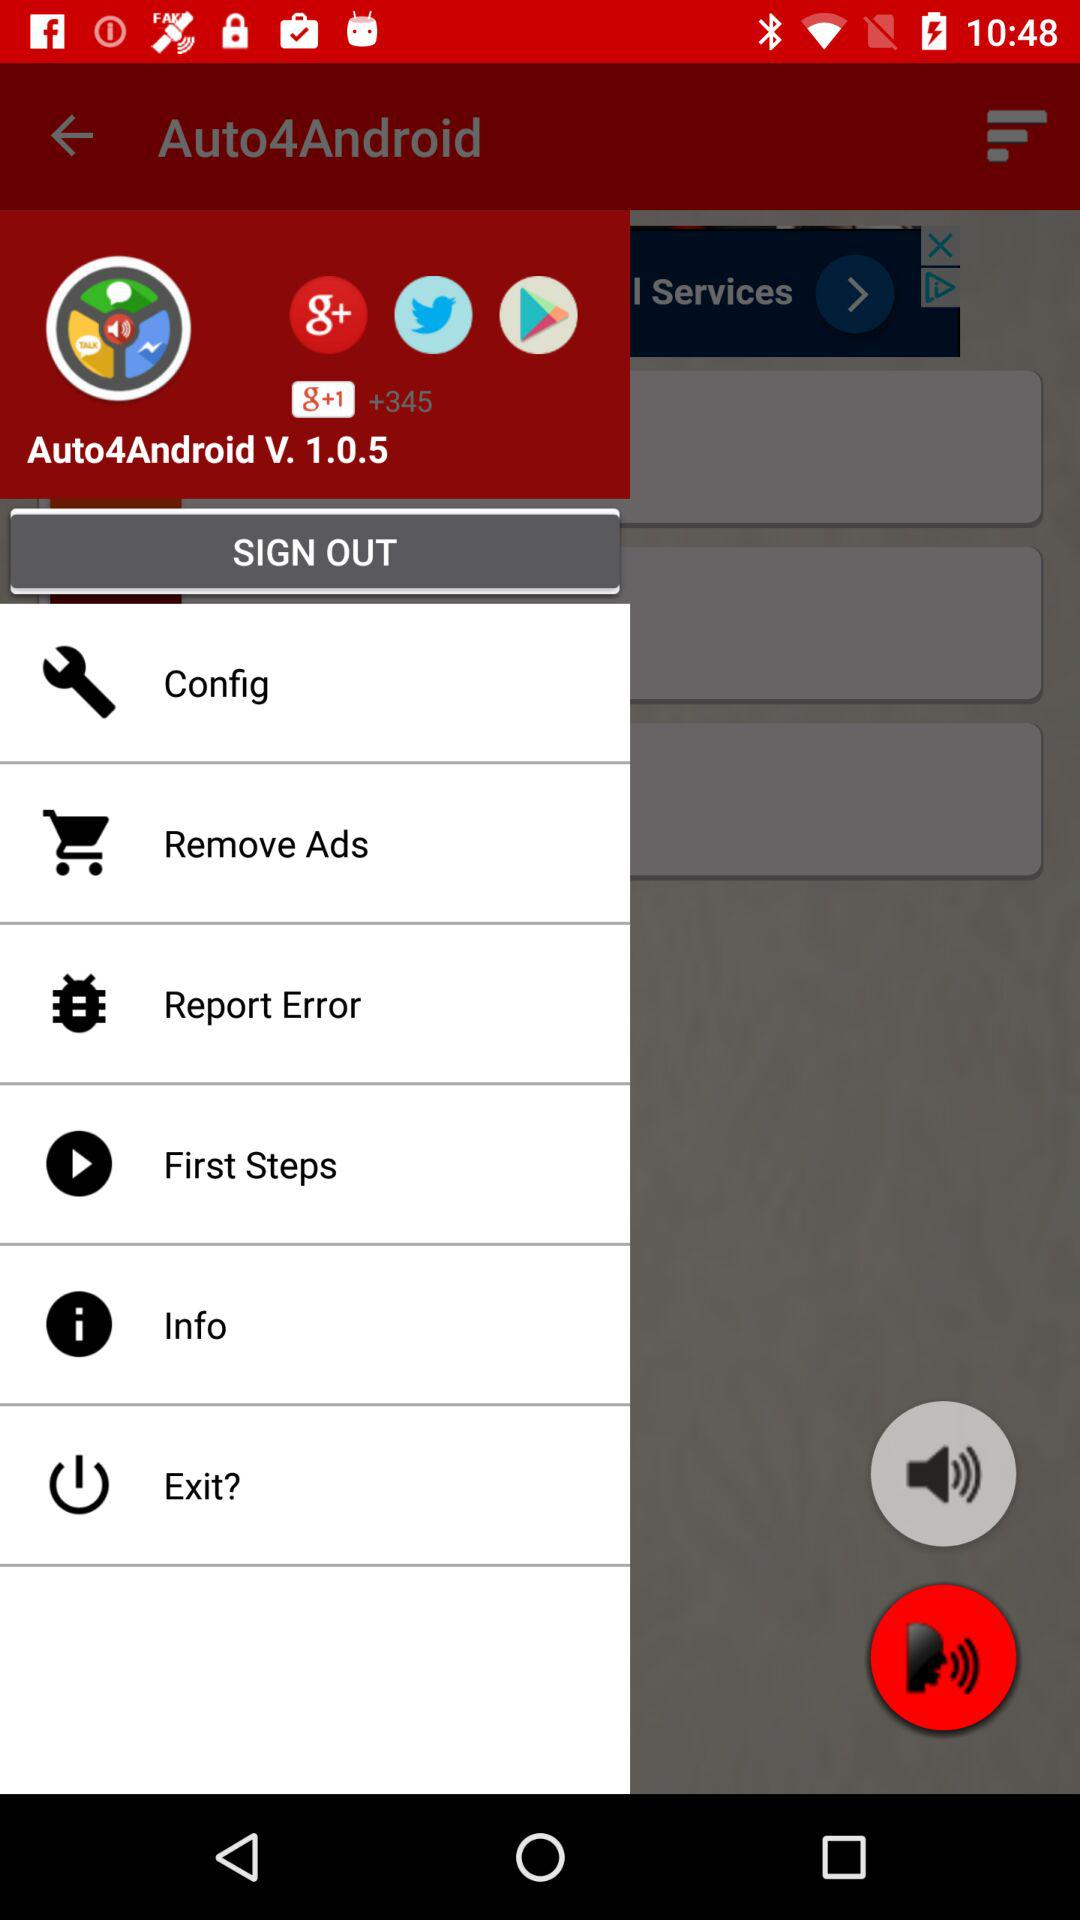What is the name of the application? The name of the application is "Auto4Android". 